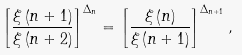<formula> <loc_0><loc_0><loc_500><loc_500>\left [ \frac { \xi \left ( n + 1 \right ) } { \xi \left ( n + 2 \right ) } \right ] ^ { \Delta _ { n } } = \left [ \frac { \xi \left ( n \right ) } { \xi \left ( n + 1 \right ) } \right ] ^ { \Delta _ { n + 1 } } ,</formula> 